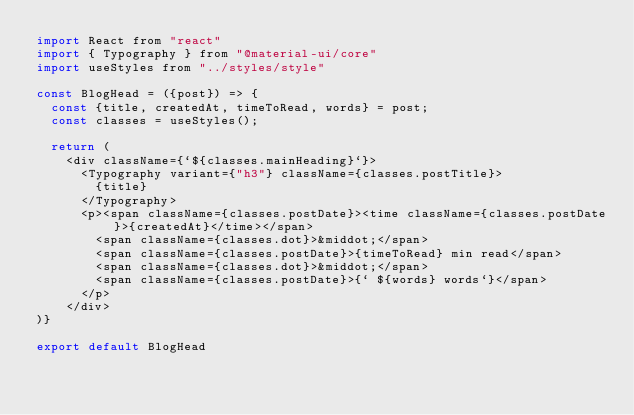Convert code to text. <code><loc_0><loc_0><loc_500><loc_500><_JavaScript_>import React from "react"
import { Typography } from "@material-ui/core"
import useStyles from "../styles/style"

const BlogHead = ({post}) => {
  const {title, createdAt, timeToRead, words} = post;
  const classes = useStyles();

  return (
    <div className={`${classes.mainHeading}`}>
      <Typography variant={"h3"} className={classes.postTitle}>
        {title}
      </Typography>
      <p><span className={classes.postDate}><time className={classes.postDate}>{createdAt}</time></span>
        <span className={classes.dot}>&middot;</span>
        <span className={classes.postDate}>{timeToRead} min read</span>
        <span className={classes.dot}>&middot;</span>
        <span className={classes.postDate}>{` ${words} words`}</span>
      </p>
    </div>
)}

export default BlogHead</code> 